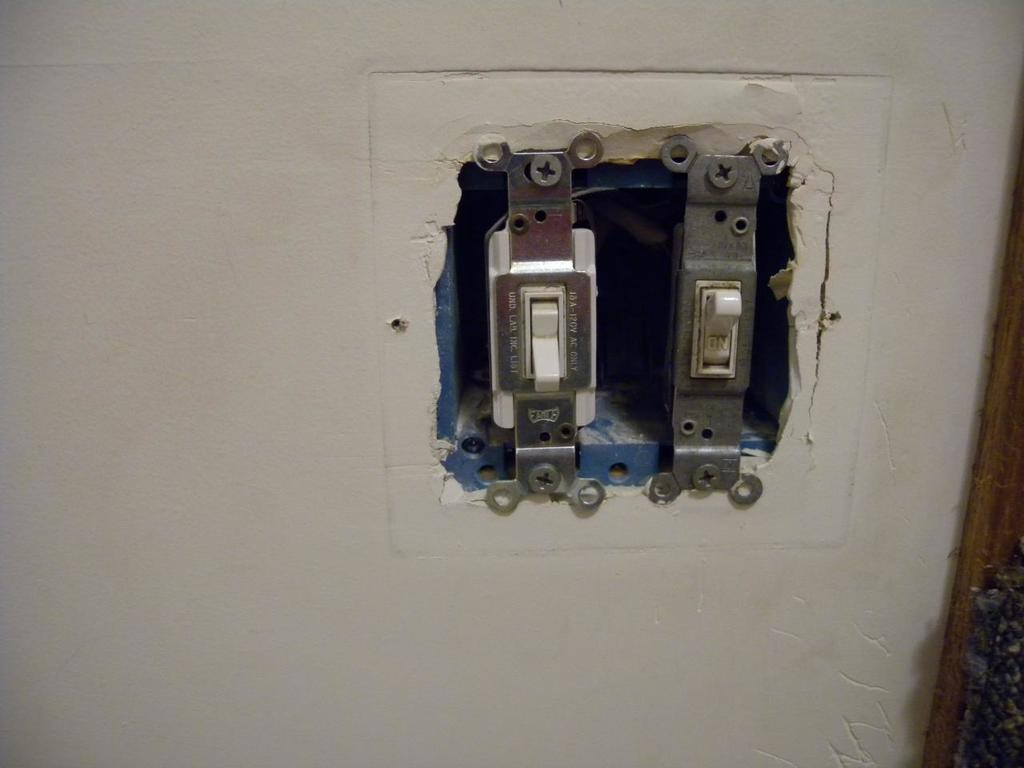How many electrical switches can be seen in the image? There are two electrical switches in the image. Where are the switches located? The switches are attached to a wall. What type of bushes can be seen growing near the switches in the image? There are no bushes present in the image; it only features two electrical switches attached to a wall. 